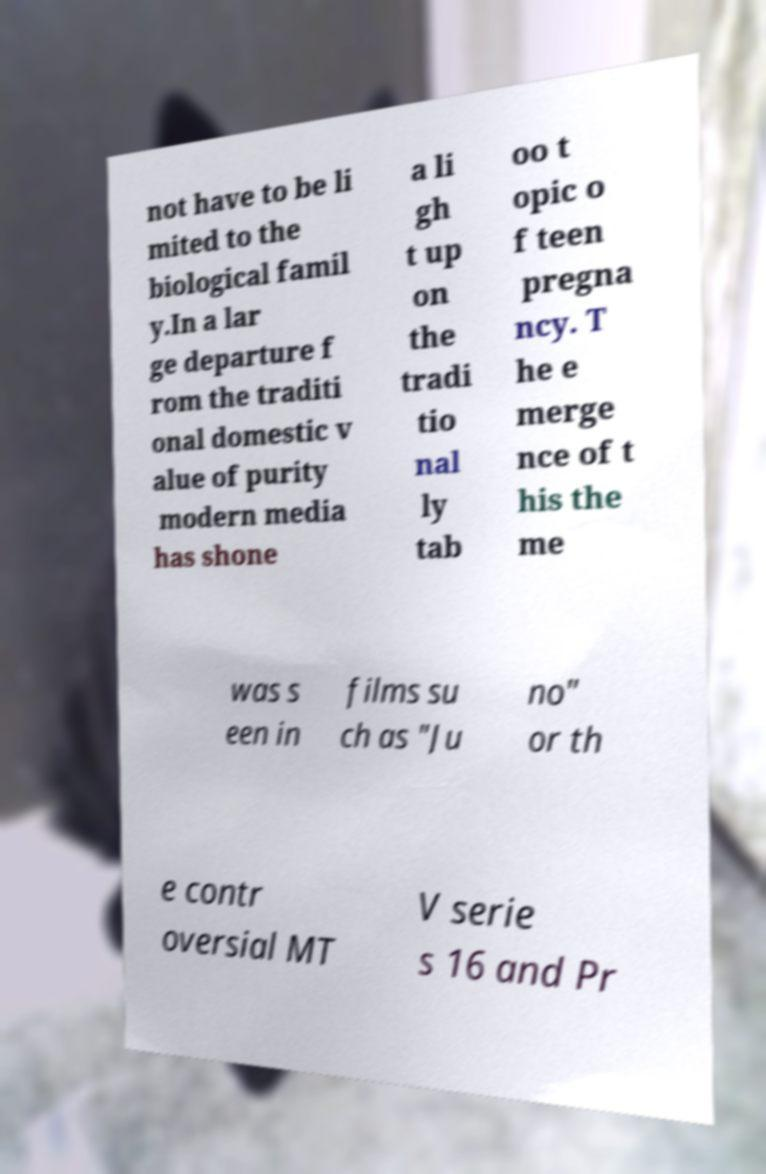I need the written content from this picture converted into text. Can you do that? not have to be li mited to the biological famil y.In a lar ge departure f rom the traditi onal domestic v alue of purity modern media has shone a li gh t up on the tradi tio nal ly tab oo t opic o f teen pregna ncy. T he e merge nce of t his the me was s een in films su ch as "Ju no" or th e contr oversial MT V serie s 16 and Pr 